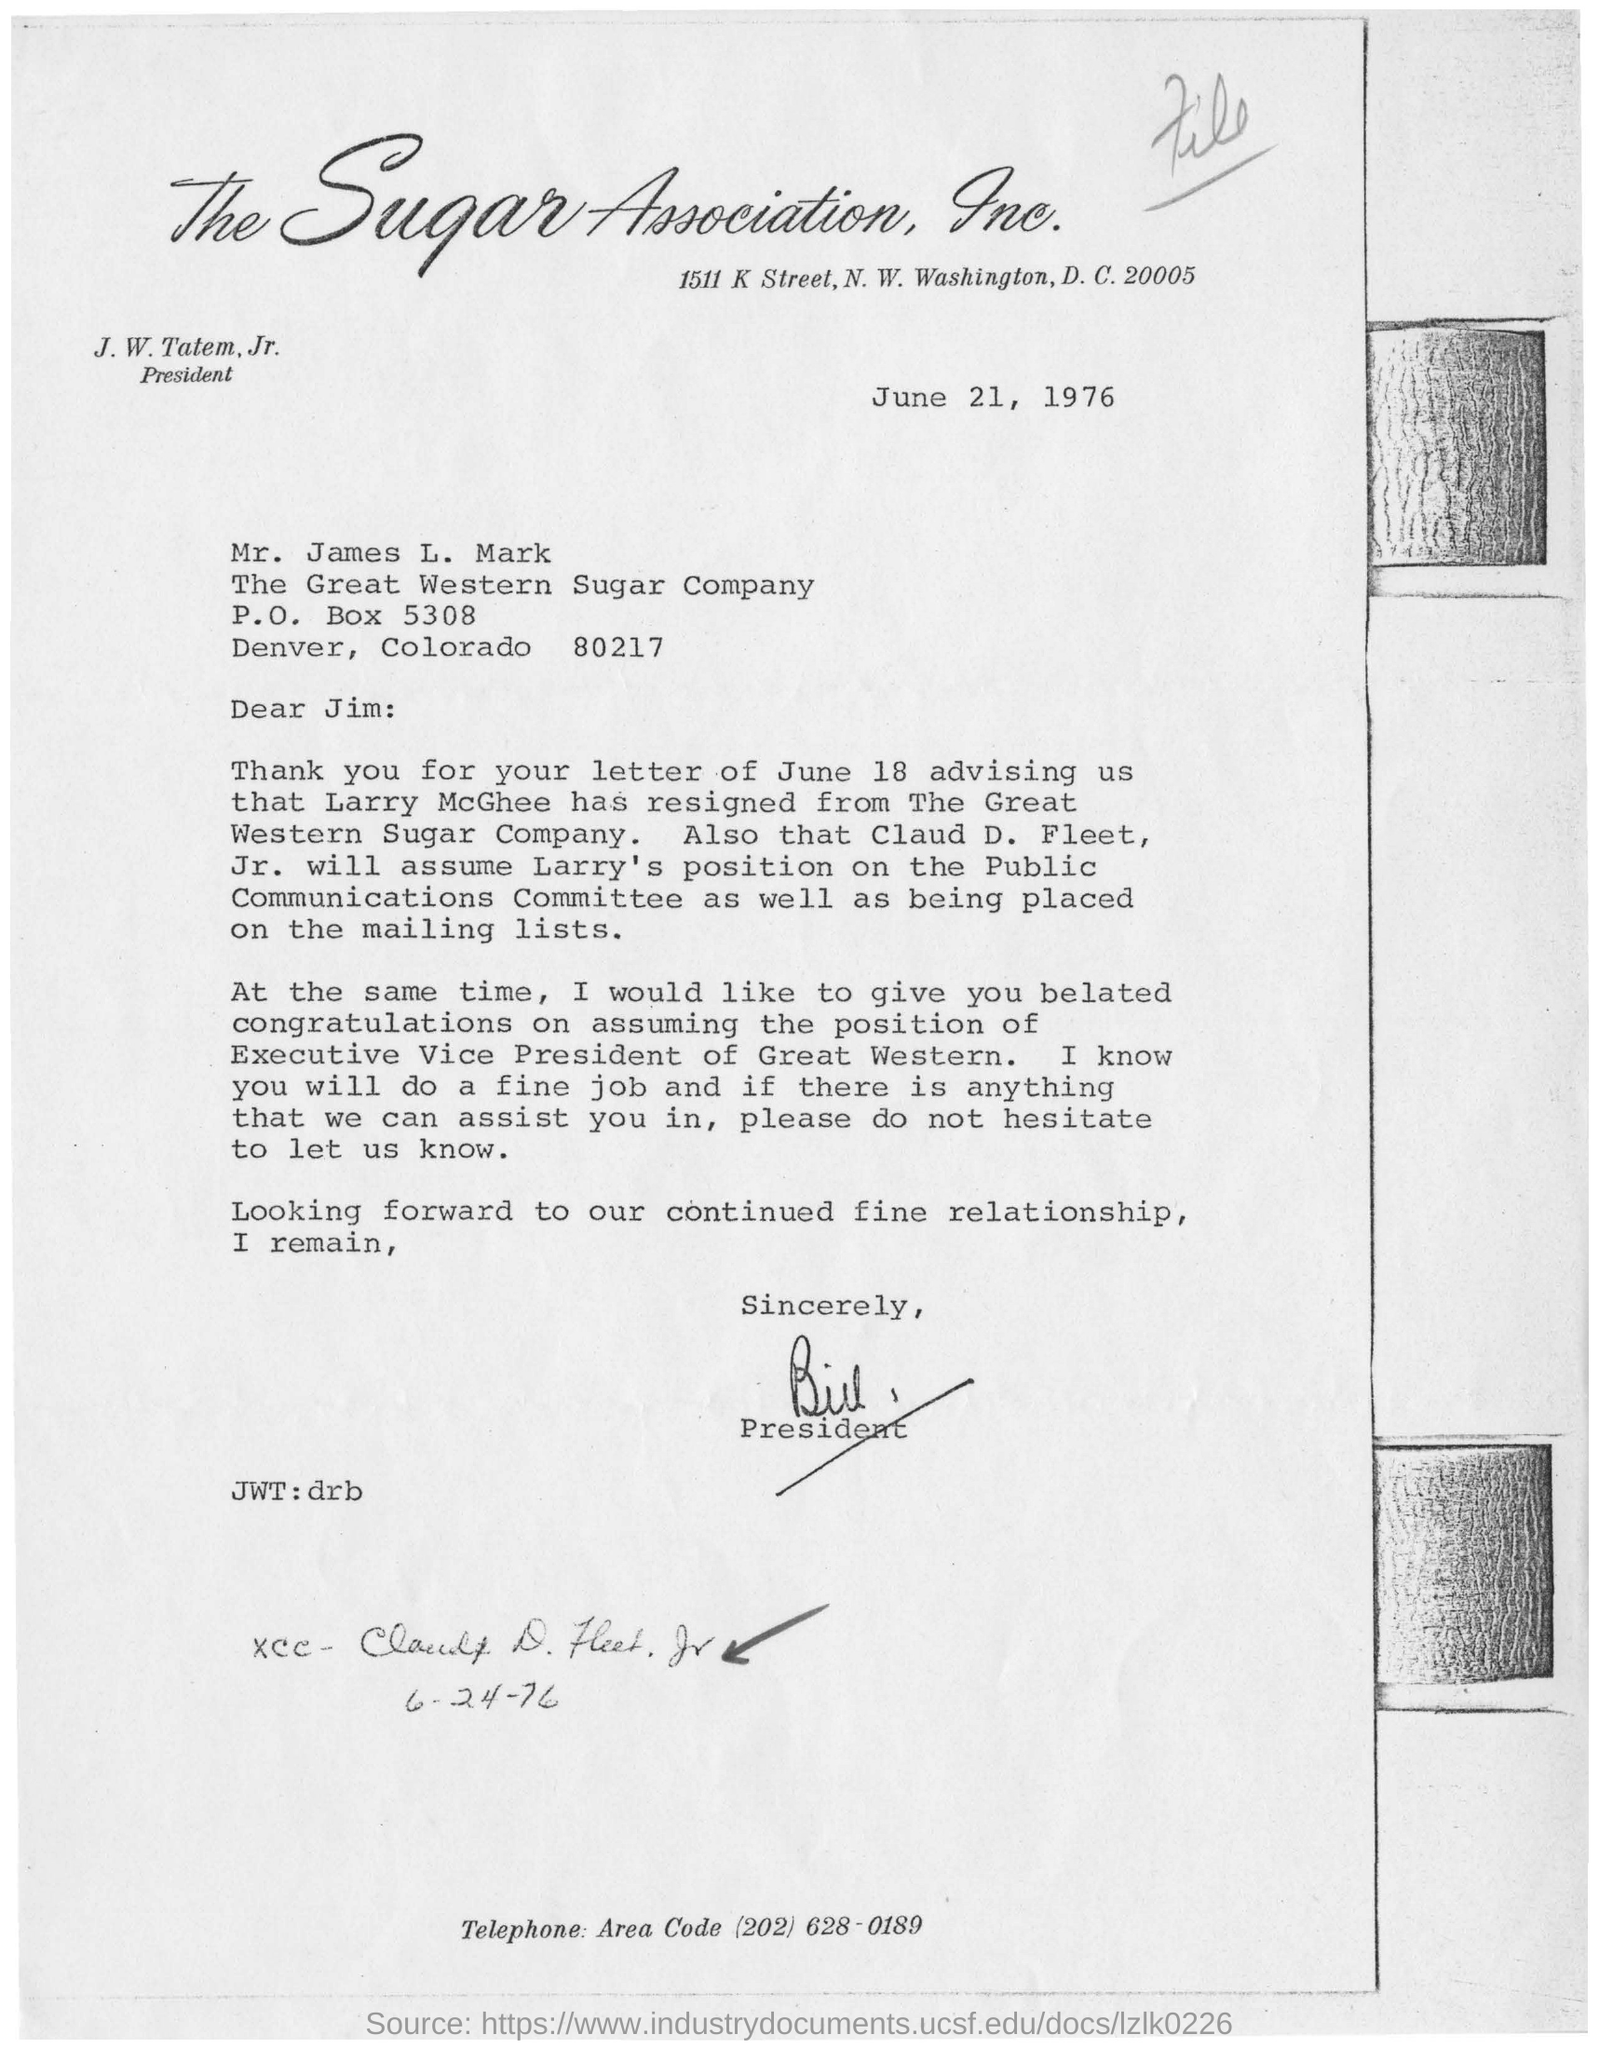What is the date mentioned above?
Your answer should be very brief. June 21, 1976. 